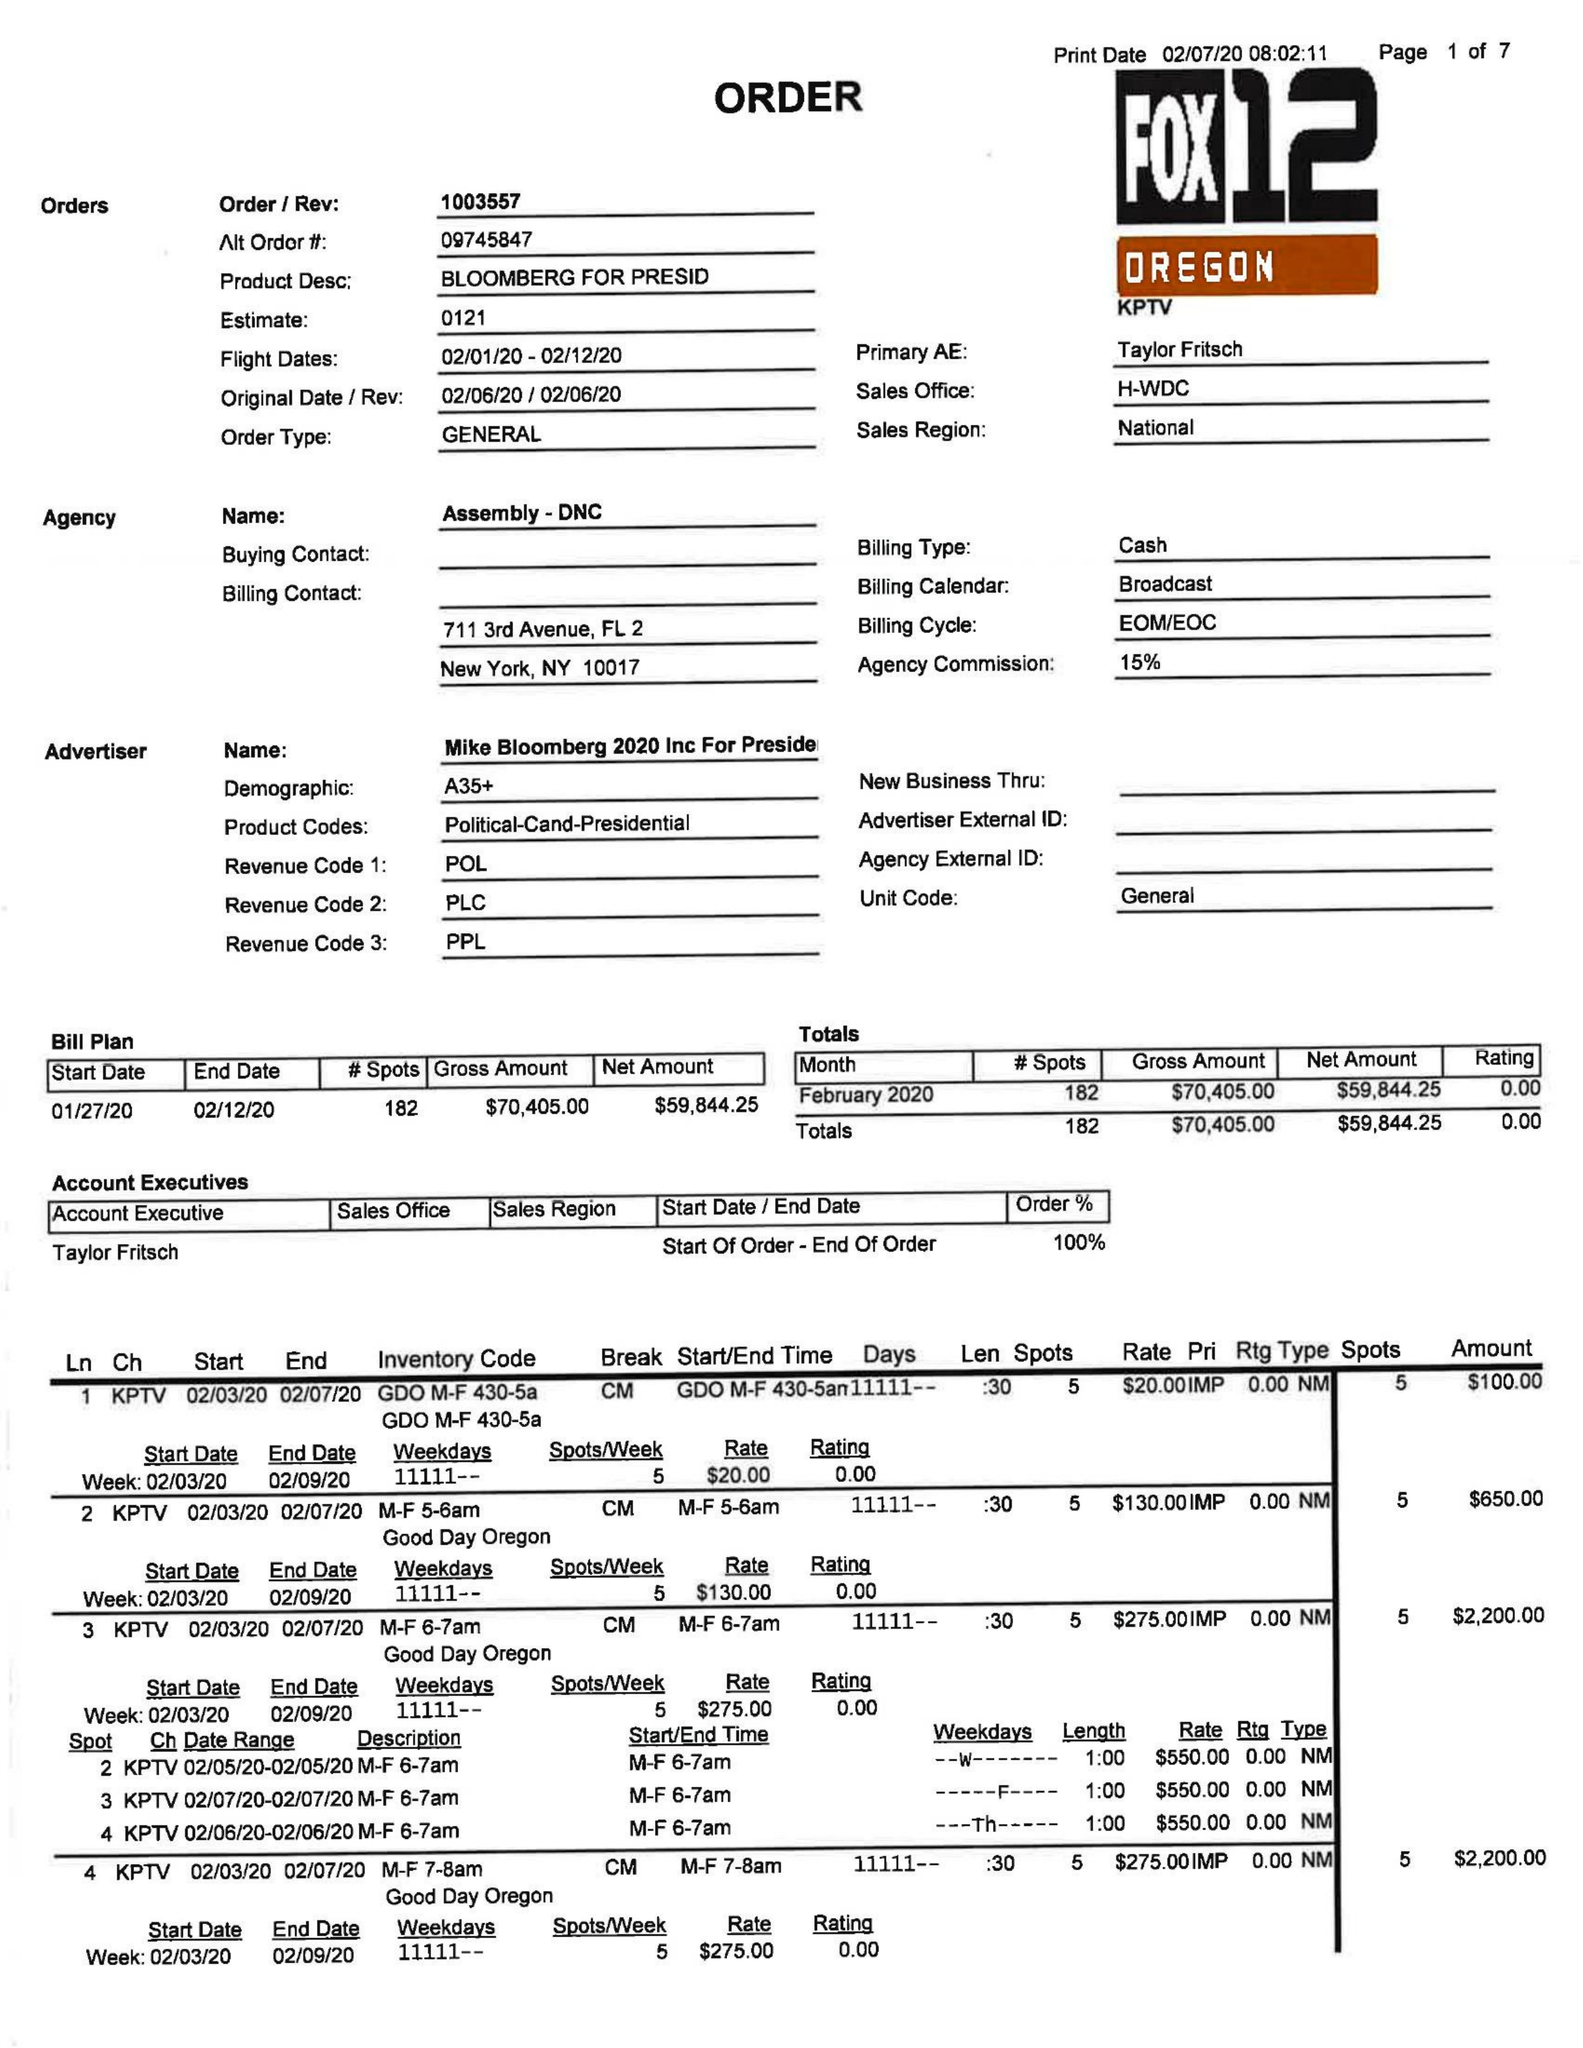What is the value for the flight_from?
Answer the question using a single word or phrase. 02/01/20 